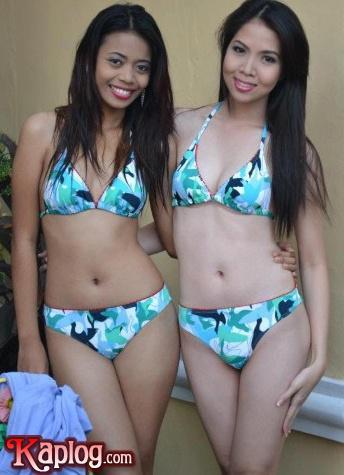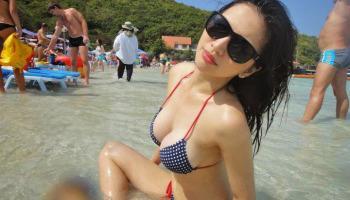The first image is the image on the left, the second image is the image on the right. Evaluate the accuracy of this statement regarding the images: "The combined images contain four bikini models, and none have sunglasses covering their eyes.". Is it true? Answer yes or no. No. The first image is the image on the left, the second image is the image on the right. Given the left and right images, does the statement "There are an equal number of girls in both images." hold true? Answer yes or no. No. 